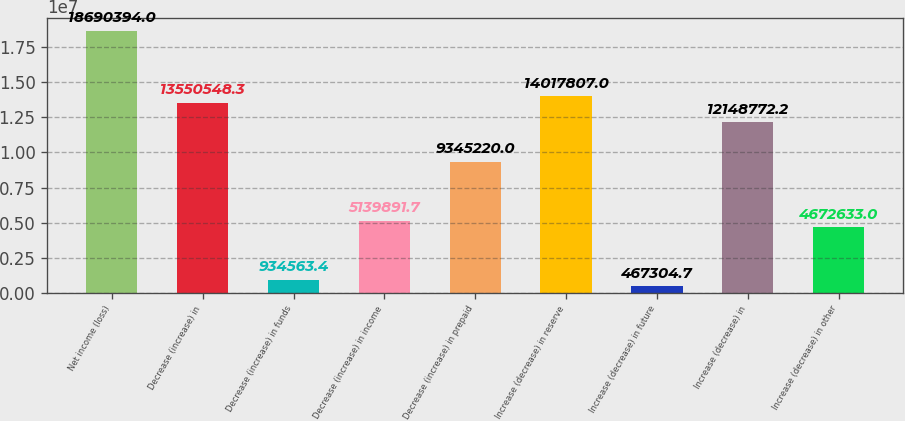Convert chart to OTSL. <chart><loc_0><loc_0><loc_500><loc_500><bar_chart><fcel>Net income (loss)<fcel>Decrease (increase) in<fcel>Decrease (increase) in funds<fcel>Decrease (increase) in income<fcel>Decrease (increase) in prepaid<fcel>Increase (decrease) in reserve<fcel>Increase (decrease) in future<fcel>Increase (decrease) in<fcel>Increase (decrease) in other<nl><fcel>1.86904e+07<fcel>1.35505e+07<fcel>934563<fcel>5.13989e+06<fcel>9.34522e+06<fcel>1.40178e+07<fcel>467305<fcel>1.21488e+07<fcel>4.67263e+06<nl></chart> 